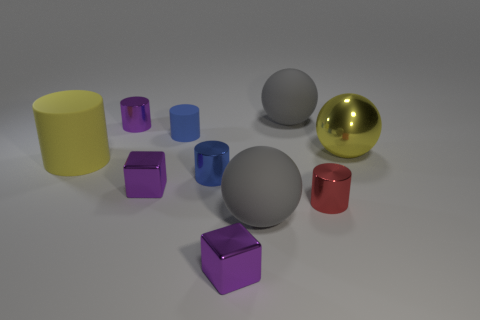Subtract all rubber spheres. How many spheres are left? 1 Subtract all yellow cylinders. How many cylinders are left? 4 Subtract all brown cylinders. Subtract all blue blocks. How many cylinders are left? 5 Subtract all spheres. How many objects are left? 7 Add 9 tiny blue metallic cylinders. How many tiny blue metallic cylinders are left? 10 Add 3 small red metallic cylinders. How many small red metallic cylinders exist? 4 Subtract 0 red balls. How many objects are left? 10 Subtract all rubber objects. Subtract all tiny shiny objects. How many objects are left? 1 